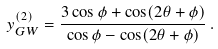<formula> <loc_0><loc_0><loc_500><loc_500>y _ { G W } ^ { ( 2 ) } = \frac { 3 \cos \phi + \cos ( 2 \theta + \phi ) } { \cos \phi - \cos ( 2 \theta + \phi ) } \, .</formula> 